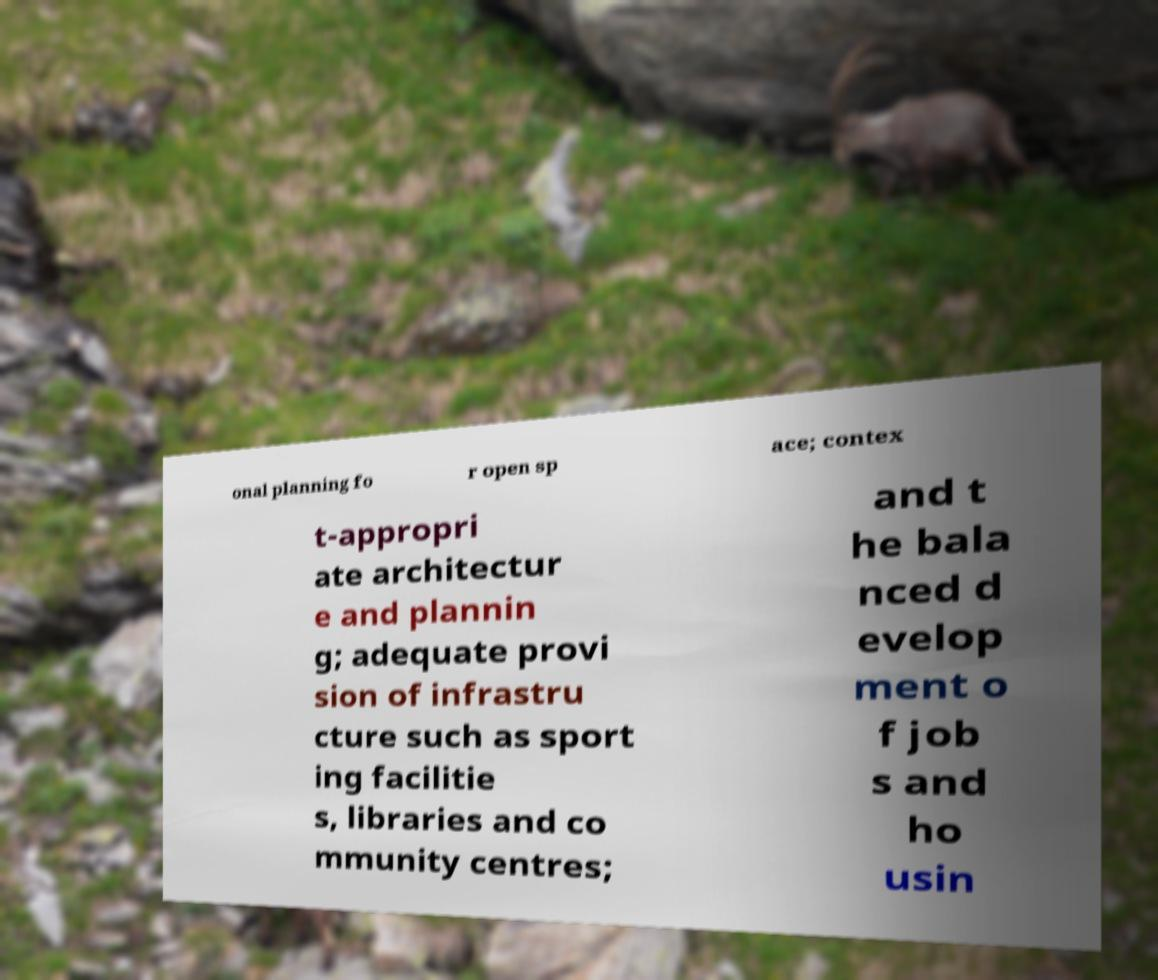Can you accurately transcribe the text from the provided image for me? onal planning fo r open sp ace; contex t-appropri ate architectur e and plannin g; adequate provi sion of infrastru cture such as sport ing facilitie s, libraries and co mmunity centres; and t he bala nced d evelop ment o f job s and ho usin 